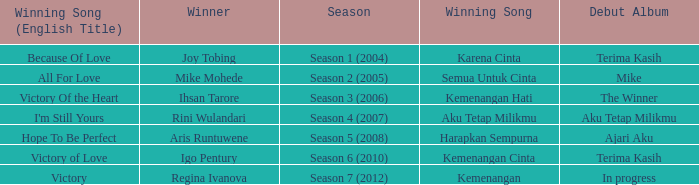Which album debuted in season 2 (2005)? Mike. 